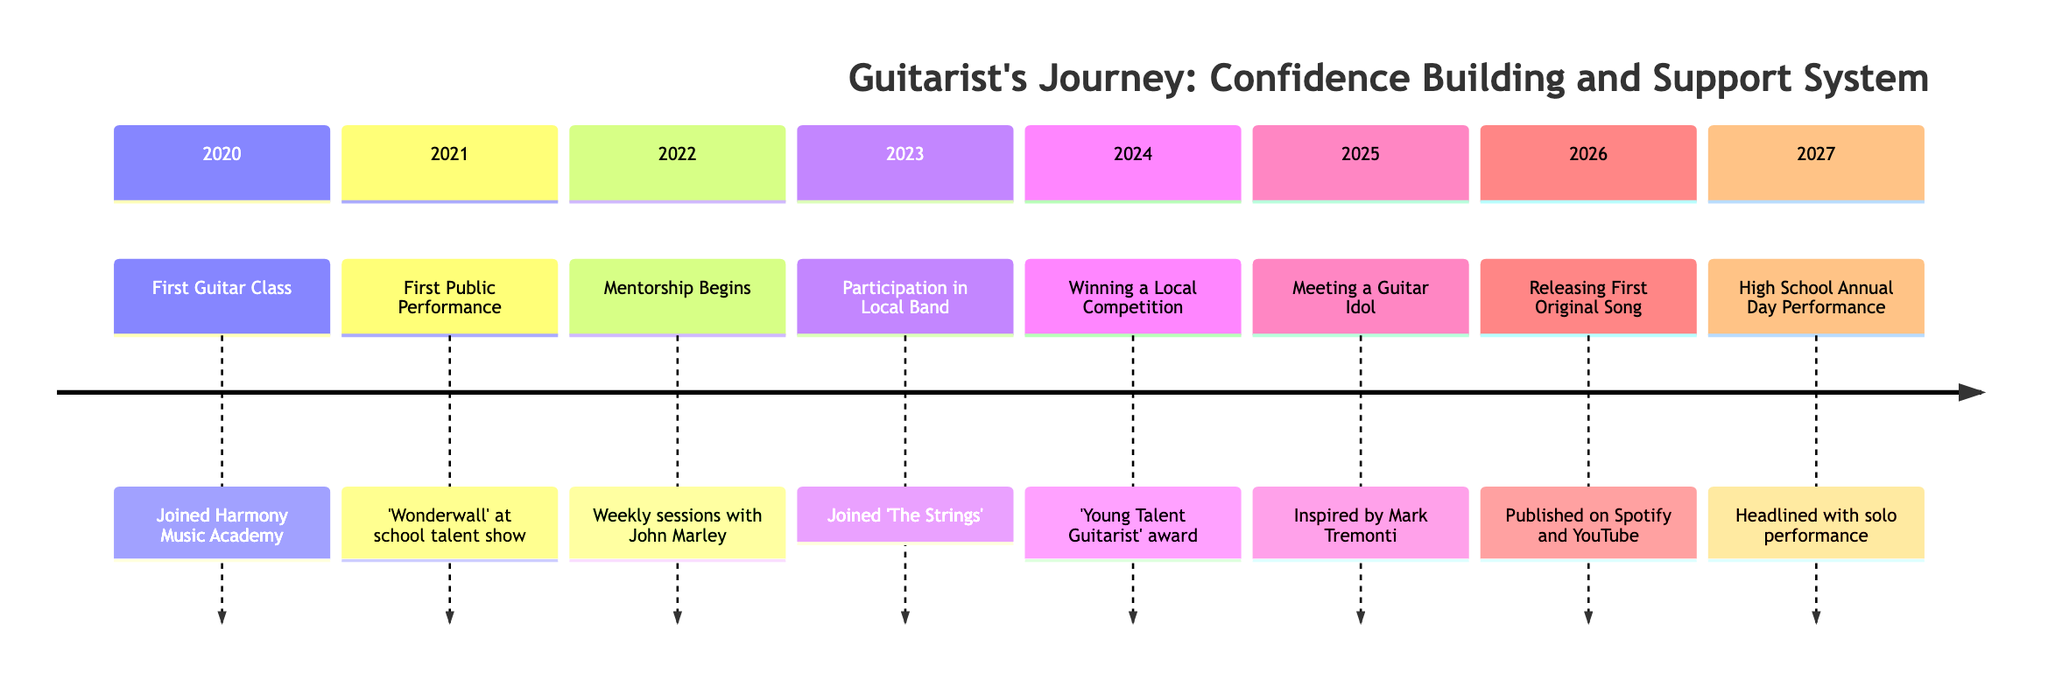What was the first event in the timeline? The first event is listed as "First Guitar Class," which happened in 2020.
Answer: First Guitar Class How many events are represented in the timeline? The timeline contains eight distinct events spanning from 2020 to 2027, each representing a key moment in the journey.
Answer: 8 What year did the mentorship begin? According to the timeline, mentorship began in 2022.
Answer: 2022 Which event involved public performance? The event titled "First Public Performance" occurred in 2021, where a song was performed at a talent show.
Answer: First Public Performance What is the last event mentioned? The final event listed in the timeline is "High School Annual Day Performance," which took place in 2027.
Answer: High School Annual Day Performance In which year was the "Young Talent Guitarist" award won? The timeline states that the "Winning a Local Competition" event, during which the award was received, occurred in 2024.
Answer: 2024 How did joining "The Strings" affect confidence? Joining "The Strings" in 2023 led to regular rehearsals and smaller performances, which helped boost confidence significantly.
Answer: Boosted confidence What notable figure was met as an "idol" in 2025? The timeline indicates that in 2025, the individual met Mark Tremonti, who is recognized as a famous guitarist and idol.
Answer: Mark Tremonti What significant milestone occurred in 2026? The milestone for the year 2026 was the release of the first original song on platforms like Spotify and YouTube, marking an important achievement.
Answer: Releasing First Original Song 